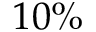<formula> <loc_0><loc_0><loc_500><loc_500>1 0 \%</formula> 